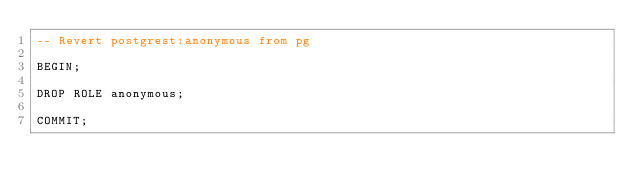<code> <loc_0><loc_0><loc_500><loc_500><_SQL_>-- Revert postgrest:anonymous from pg

BEGIN;

DROP ROLE anonymous;

COMMIT;
</code> 